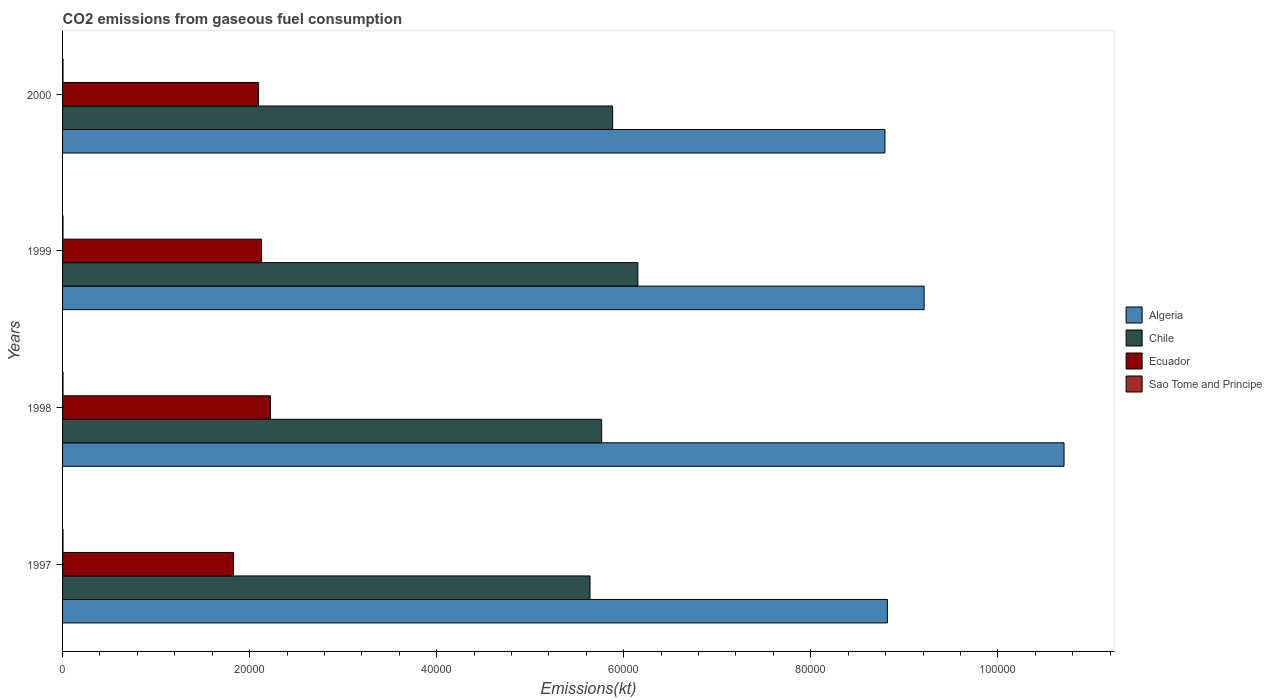Are the number of bars per tick equal to the number of legend labels?
Your response must be concise. Yes. Are the number of bars on each tick of the Y-axis equal?
Provide a short and direct response. Yes. What is the amount of CO2 emitted in Chile in 1999?
Provide a short and direct response. 6.15e+04. Across all years, what is the maximum amount of CO2 emitted in Sao Tome and Principe?
Provide a short and direct response. 47.67. Across all years, what is the minimum amount of CO2 emitted in Ecuador?
Your answer should be very brief. 1.83e+04. In which year was the amount of CO2 emitted in Ecuador maximum?
Offer a very short reply. 1998. What is the total amount of CO2 emitted in Ecuador in the graph?
Keep it short and to the point. 8.27e+04. What is the difference between the amount of CO2 emitted in Chile in 1997 and that in 1998?
Provide a short and direct response. -1246.78. What is the difference between the amount of CO2 emitted in Algeria in 1998 and the amount of CO2 emitted in Ecuador in 1999?
Keep it short and to the point. 8.58e+04. What is the average amount of CO2 emitted in Sao Tome and Principe per year?
Make the answer very short. 47.67. In the year 1999, what is the difference between the amount of CO2 emitted in Ecuador and amount of CO2 emitted in Chile?
Provide a succinct answer. -4.02e+04. In how many years, is the amount of CO2 emitted in Chile greater than 76000 kt?
Provide a short and direct response. 0. What is the ratio of the amount of CO2 emitted in Chile in 1997 to that in 1999?
Your answer should be compact. 0.92. Is the amount of CO2 emitted in Sao Tome and Principe in 1999 less than that in 2000?
Your answer should be very brief. No. Is the difference between the amount of CO2 emitted in Ecuador in 1997 and 1998 greater than the difference between the amount of CO2 emitted in Chile in 1997 and 1998?
Keep it short and to the point. No. What is the difference between the highest and the second highest amount of CO2 emitted in Ecuador?
Your answer should be very brief. 957.09. What is the difference between the highest and the lowest amount of CO2 emitted in Ecuador?
Your answer should be very brief. 3953.03. Is the sum of the amount of CO2 emitted in Ecuador in 1997 and 1999 greater than the maximum amount of CO2 emitted in Chile across all years?
Give a very brief answer. No. What does the 1st bar from the bottom in 1997 represents?
Give a very brief answer. Algeria. Are the values on the major ticks of X-axis written in scientific E-notation?
Make the answer very short. No. Does the graph contain grids?
Keep it short and to the point. No. How many legend labels are there?
Your answer should be compact. 4. How are the legend labels stacked?
Give a very brief answer. Vertical. What is the title of the graph?
Provide a succinct answer. CO2 emissions from gaseous fuel consumption. What is the label or title of the X-axis?
Your answer should be compact. Emissions(kt). What is the Emissions(kt) of Algeria in 1997?
Offer a very short reply. 8.82e+04. What is the Emissions(kt) in Chile in 1997?
Offer a very short reply. 5.64e+04. What is the Emissions(kt) of Ecuador in 1997?
Offer a very short reply. 1.83e+04. What is the Emissions(kt) of Sao Tome and Principe in 1997?
Your answer should be compact. 47.67. What is the Emissions(kt) in Algeria in 1998?
Give a very brief answer. 1.07e+05. What is the Emissions(kt) of Chile in 1998?
Make the answer very short. 5.76e+04. What is the Emissions(kt) of Ecuador in 1998?
Keep it short and to the point. 2.22e+04. What is the Emissions(kt) of Sao Tome and Principe in 1998?
Offer a terse response. 47.67. What is the Emissions(kt) in Algeria in 1999?
Keep it short and to the point. 9.21e+04. What is the Emissions(kt) of Chile in 1999?
Keep it short and to the point. 6.15e+04. What is the Emissions(kt) in Ecuador in 1999?
Provide a short and direct response. 2.13e+04. What is the Emissions(kt) in Sao Tome and Principe in 1999?
Keep it short and to the point. 47.67. What is the Emissions(kt) of Algeria in 2000?
Provide a succinct answer. 8.79e+04. What is the Emissions(kt) of Chile in 2000?
Provide a succinct answer. 5.88e+04. What is the Emissions(kt) in Ecuador in 2000?
Offer a very short reply. 2.09e+04. What is the Emissions(kt) in Sao Tome and Principe in 2000?
Keep it short and to the point. 47.67. Across all years, what is the maximum Emissions(kt) in Algeria?
Ensure brevity in your answer.  1.07e+05. Across all years, what is the maximum Emissions(kt) in Chile?
Make the answer very short. 6.15e+04. Across all years, what is the maximum Emissions(kt) of Ecuador?
Your answer should be compact. 2.22e+04. Across all years, what is the maximum Emissions(kt) of Sao Tome and Principe?
Keep it short and to the point. 47.67. Across all years, what is the minimum Emissions(kt) in Algeria?
Your response must be concise. 8.79e+04. Across all years, what is the minimum Emissions(kt) in Chile?
Give a very brief answer. 5.64e+04. Across all years, what is the minimum Emissions(kt) of Ecuador?
Keep it short and to the point. 1.83e+04. Across all years, what is the minimum Emissions(kt) of Sao Tome and Principe?
Offer a very short reply. 47.67. What is the total Emissions(kt) in Algeria in the graph?
Ensure brevity in your answer.  3.75e+05. What is the total Emissions(kt) in Chile in the graph?
Your answer should be very brief. 2.34e+05. What is the total Emissions(kt) of Ecuador in the graph?
Your answer should be very brief. 8.27e+04. What is the total Emissions(kt) in Sao Tome and Principe in the graph?
Your answer should be compact. 190.68. What is the difference between the Emissions(kt) in Algeria in 1997 and that in 1998?
Provide a short and direct response. -1.89e+04. What is the difference between the Emissions(kt) of Chile in 1997 and that in 1998?
Offer a very short reply. -1246.78. What is the difference between the Emissions(kt) in Ecuador in 1997 and that in 1998?
Your answer should be compact. -3953.03. What is the difference between the Emissions(kt) in Algeria in 1997 and that in 1999?
Your response must be concise. -3923.69. What is the difference between the Emissions(kt) of Chile in 1997 and that in 1999?
Ensure brevity in your answer.  -5119.13. What is the difference between the Emissions(kt) in Ecuador in 1997 and that in 1999?
Your answer should be compact. -2995.94. What is the difference between the Emissions(kt) in Sao Tome and Principe in 1997 and that in 1999?
Provide a succinct answer. 0. What is the difference between the Emissions(kt) in Algeria in 1997 and that in 2000?
Provide a short and direct response. 264.02. What is the difference between the Emissions(kt) in Chile in 1997 and that in 2000?
Offer a terse response. -2420.22. What is the difference between the Emissions(kt) of Ecuador in 1997 and that in 2000?
Offer a terse response. -2665.91. What is the difference between the Emissions(kt) in Algeria in 1998 and that in 1999?
Offer a terse response. 1.50e+04. What is the difference between the Emissions(kt) in Chile in 1998 and that in 1999?
Ensure brevity in your answer.  -3872.35. What is the difference between the Emissions(kt) of Ecuador in 1998 and that in 1999?
Provide a succinct answer. 957.09. What is the difference between the Emissions(kt) in Sao Tome and Principe in 1998 and that in 1999?
Your answer should be very brief. 0. What is the difference between the Emissions(kt) of Algeria in 1998 and that in 2000?
Your answer should be compact. 1.91e+04. What is the difference between the Emissions(kt) of Chile in 1998 and that in 2000?
Provide a short and direct response. -1173.44. What is the difference between the Emissions(kt) in Ecuador in 1998 and that in 2000?
Offer a very short reply. 1287.12. What is the difference between the Emissions(kt) of Algeria in 1999 and that in 2000?
Make the answer very short. 4187.71. What is the difference between the Emissions(kt) of Chile in 1999 and that in 2000?
Keep it short and to the point. 2698.91. What is the difference between the Emissions(kt) of Ecuador in 1999 and that in 2000?
Make the answer very short. 330.03. What is the difference between the Emissions(kt) in Sao Tome and Principe in 1999 and that in 2000?
Ensure brevity in your answer.  0. What is the difference between the Emissions(kt) in Algeria in 1997 and the Emissions(kt) in Chile in 1998?
Offer a very short reply. 3.06e+04. What is the difference between the Emissions(kt) in Algeria in 1997 and the Emissions(kt) in Ecuador in 1998?
Provide a succinct answer. 6.60e+04. What is the difference between the Emissions(kt) of Algeria in 1997 and the Emissions(kt) of Sao Tome and Principe in 1998?
Ensure brevity in your answer.  8.81e+04. What is the difference between the Emissions(kt) of Chile in 1997 and the Emissions(kt) of Ecuador in 1998?
Offer a terse response. 3.42e+04. What is the difference between the Emissions(kt) of Chile in 1997 and the Emissions(kt) of Sao Tome and Principe in 1998?
Offer a very short reply. 5.63e+04. What is the difference between the Emissions(kt) in Ecuador in 1997 and the Emissions(kt) in Sao Tome and Principe in 1998?
Keep it short and to the point. 1.82e+04. What is the difference between the Emissions(kt) of Algeria in 1997 and the Emissions(kt) of Chile in 1999?
Provide a short and direct response. 2.67e+04. What is the difference between the Emissions(kt) in Algeria in 1997 and the Emissions(kt) in Ecuador in 1999?
Your answer should be very brief. 6.69e+04. What is the difference between the Emissions(kt) in Algeria in 1997 and the Emissions(kt) in Sao Tome and Principe in 1999?
Provide a short and direct response. 8.81e+04. What is the difference between the Emissions(kt) in Chile in 1997 and the Emissions(kt) in Ecuador in 1999?
Ensure brevity in your answer.  3.51e+04. What is the difference between the Emissions(kt) in Chile in 1997 and the Emissions(kt) in Sao Tome and Principe in 1999?
Your response must be concise. 5.63e+04. What is the difference between the Emissions(kt) in Ecuador in 1997 and the Emissions(kt) in Sao Tome and Principe in 1999?
Your answer should be very brief. 1.82e+04. What is the difference between the Emissions(kt) of Algeria in 1997 and the Emissions(kt) of Chile in 2000?
Give a very brief answer. 2.94e+04. What is the difference between the Emissions(kt) of Algeria in 1997 and the Emissions(kt) of Ecuador in 2000?
Provide a short and direct response. 6.73e+04. What is the difference between the Emissions(kt) in Algeria in 1997 and the Emissions(kt) in Sao Tome and Principe in 2000?
Your answer should be compact. 8.81e+04. What is the difference between the Emissions(kt) in Chile in 1997 and the Emissions(kt) in Ecuador in 2000?
Ensure brevity in your answer.  3.55e+04. What is the difference between the Emissions(kt) in Chile in 1997 and the Emissions(kt) in Sao Tome and Principe in 2000?
Keep it short and to the point. 5.63e+04. What is the difference between the Emissions(kt) of Ecuador in 1997 and the Emissions(kt) of Sao Tome and Principe in 2000?
Provide a short and direct response. 1.82e+04. What is the difference between the Emissions(kt) in Algeria in 1998 and the Emissions(kt) in Chile in 1999?
Offer a very short reply. 4.56e+04. What is the difference between the Emissions(kt) of Algeria in 1998 and the Emissions(kt) of Ecuador in 1999?
Your answer should be very brief. 8.58e+04. What is the difference between the Emissions(kt) of Algeria in 1998 and the Emissions(kt) of Sao Tome and Principe in 1999?
Ensure brevity in your answer.  1.07e+05. What is the difference between the Emissions(kt) in Chile in 1998 and the Emissions(kt) in Ecuador in 1999?
Keep it short and to the point. 3.64e+04. What is the difference between the Emissions(kt) of Chile in 1998 and the Emissions(kt) of Sao Tome and Principe in 1999?
Offer a terse response. 5.76e+04. What is the difference between the Emissions(kt) in Ecuador in 1998 and the Emissions(kt) in Sao Tome and Principe in 1999?
Your answer should be compact. 2.22e+04. What is the difference between the Emissions(kt) of Algeria in 1998 and the Emissions(kt) of Chile in 2000?
Make the answer very short. 4.83e+04. What is the difference between the Emissions(kt) in Algeria in 1998 and the Emissions(kt) in Ecuador in 2000?
Your answer should be compact. 8.61e+04. What is the difference between the Emissions(kt) of Algeria in 1998 and the Emissions(kt) of Sao Tome and Principe in 2000?
Your response must be concise. 1.07e+05. What is the difference between the Emissions(kt) of Chile in 1998 and the Emissions(kt) of Ecuador in 2000?
Give a very brief answer. 3.67e+04. What is the difference between the Emissions(kt) in Chile in 1998 and the Emissions(kt) in Sao Tome and Principe in 2000?
Your answer should be very brief. 5.76e+04. What is the difference between the Emissions(kt) in Ecuador in 1998 and the Emissions(kt) in Sao Tome and Principe in 2000?
Make the answer very short. 2.22e+04. What is the difference between the Emissions(kt) of Algeria in 1999 and the Emissions(kt) of Chile in 2000?
Ensure brevity in your answer.  3.33e+04. What is the difference between the Emissions(kt) in Algeria in 1999 and the Emissions(kt) in Ecuador in 2000?
Your response must be concise. 7.12e+04. What is the difference between the Emissions(kt) of Algeria in 1999 and the Emissions(kt) of Sao Tome and Principe in 2000?
Offer a very short reply. 9.21e+04. What is the difference between the Emissions(kt) of Chile in 1999 and the Emissions(kt) of Ecuador in 2000?
Offer a very short reply. 4.06e+04. What is the difference between the Emissions(kt) of Chile in 1999 and the Emissions(kt) of Sao Tome and Principe in 2000?
Make the answer very short. 6.15e+04. What is the difference between the Emissions(kt) of Ecuador in 1999 and the Emissions(kt) of Sao Tome and Principe in 2000?
Make the answer very short. 2.12e+04. What is the average Emissions(kt) in Algeria per year?
Your response must be concise. 9.38e+04. What is the average Emissions(kt) in Chile per year?
Your answer should be very brief. 5.86e+04. What is the average Emissions(kt) in Ecuador per year?
Your response must be concise. 2.07e+04. What is the average Emissions(kt) in Sao Tome and Principe per year?
Give a very brief answer. 47.67. In the year 1997, what is the difference between the Emissions(kt) of Algeria and Emissions(kt) of Chile?
Your answer should be very brief. 3.18e+04. In the year 1997, what is the difference between the Emissions(kt) of Algeria and Emissions(kt) of Ecuador?
Give a very brief answer. 6.99e+04. In the year 1997, what is the difference between the Emissions(kt) in Algeria and Emissions(kt) in Sao Tome and Principe?
Ensure brevity in your answer.  8.81e+04. In the year 1997, what is the difference between the Emissions(kt) of Chile and Emissions(kt) of Ecuador?
Ensure brevity in your answer.  3.81e+04. In the year 1997, what is the difference between the Emissions(kt) of Chile and Emissions(kt) of Sao Tome and Principe?
Offer a very short reply. 5.63e+04. In the year 1997, what is the difference between the Emissions(kt) in Ecuador and Emissions(kt) in Sao Tome and Principe?
Offer a very short reply. 1.82e+04. In the year 1998, what is the difference between the Emissions(kt) in Algeria and Emissions(kt) in Chile?
Offer a terse response. 4.94e+04. In the year 1998, what is the difference between the Emissions(kt) in Algeria and Emissions(kt) in Ecuador?
Offer a very short reply. 8.49e+04. In the year 1998, what is the difference between the Emissions(kt) in Algeria and Emissions(kt) in Sao Tome and Principe?
Make the answer very short. 1.07e+05. In the year 1998, what is the difference between the Emissions(kt) of Chile and Emissions(kt) of Ecuador?
Your response must be concise. 3.54e+04. In the year 1998, what is the difference between the Emissions(kt) of Chile and Emissions(kt) of Sao Tome and Principe?
Provide a short and direct response. 5.76e+04. In the year 1998, what is the difference between the Emissions(kt) in Ecuador and Emissions(kt) in Sao Tome and Principe?
Your answer should be very brief. 2.22e+04. In the year 1999, what is the difference between the Emissions(kt) in Algeria and Emissions(kt) in Chile?
Your response must be concise. 3.06e+04. In the year 1999, what is the difference between the Emissions(kt) in Algeria and Emissions(kt) in Ecuador?
Make the answer very short. 7.08e+04. In the year 1999, what is the difference between the Emissions(kt) of Algeria and Emissions(kt) of Sao Tome and Principe?
Your answer should be compact. 9.21e+04. In the year 1999, what is the difference between the Emissions(kt) of Chile and Emissions(kt) of Ecuador?
Your response must be concise. 4.02e+04. In the year 1999, what is the difference between the Emissions(kt) in Chile and Emissions(kt) in Sao Tome and Principe?
Your answer should be very brief. 6.15e+04. In the year 1999, what is the difference between the Emissions(kt) of Ecuador and Emissions(kt) of Sao Tome and Principe?
Keep it short and to the point. 2.12e+04. In the year 2000, what is the difference between the Emissions(kt) in Algeria and Emissions(kt) in Chile?
Ensure brevity in your answer.  2.91e+04. In the year 2000, what is the difference between the Emissions(kt) of Algeria and Emissions(kt) of Ecuador?
Your response must be concise. 6.70e+04. In the year 2000, what is the difference between the Emissions(kt) in Algeria and Emissions(kt) in Sao Tome and Principe?
Offer a terse response. 8.79e+04. In the year 2000, what is the difference between the Emissions(kt) of Chile and Emissions(kt) of Ecuador?
Offer a terse response. 3.79e+04. In the year 2000, what is the difference between the Emissions(kt) in Chile and Emissions(kt) in Sao Tome and Principe?
Your response must be concise. 5.88e+04. In the year 2000, what is the difference between the Emissions(kt) in Ecuador and Emissions(kt) in Sao Tome and Principe?
Give a very brief answer. 2.09e+04. What is the ratio of the Emissions(kt) of Algeria in 1997 to that in 1998?
Provide a short and direct response. 0.82. What is the ratio of the Emissions(kt) in Chile in 1997 to that in 1998?
Your response must be concise. 0.98. What is the ratio of the Emissions(kt) in Ecuador in 1997 to that in 1998?
Provide a short and direct response. 0.82. What is the ratio of the Emissions(kt) in Sao Tome and Principe in 1997 to that in 1998?
Provide a short and direct response. 1. What is the ratio of the Emissions(kt) of Algeria in 1997 to that in 1999?
Your answer should be very brief. 0.96. What is the ratio of the Emissions(kt) of Chile in 1997 to that in 1999?
Provide a succinct answer. 0.92. What is the ratio of the Emissions(kt) in Ecuador in 1997 to that in 1999?
Provide a succinct answer. 0.86. What is the ratio of the Emissions(kt) in Sao Tome and Principe in 1997 to that in 1999?
Give a very brief answer. 1. What is the ratio of the Emissions(kt) of Algeria in 1997 to that in 2000?
Give a very brief answer. 1. What is the ratio of the Emissions(kt) in Chile in 1997 to that in 2000?
Offer a very short reply. 0.96. What is the ratio of the Emissions(kt) of Ecuador in 1997 to that in 2000?
Give a very brief answer. 0.87. What is the ratio of the Emissions(kt) in Sao Tome and Principe in 1997 to that in 2000?
Give a very brief answer. 1. What is the ratio of the Emissions(kt) in Algeria in 1998 to that in 1999?
Offer a very short reply. 1.16. What is the ratio of the Emissions(kt) of Chile in 1998 to that in 1999?
Your answer should be compact. 0.94. What is the ratio of the Emissions(kt) of Ecuador in 1998 to that in 1999?
Offer a very short reply. 1.04. What is the ratio of the Emissions(kt) in Sao Tome and Principe in 1998 to that in 1999?
Give a very brief answer. 1. What is the ratio of the Emissions(kt) in Algeria in 1998 to that in 2000?
Provide a succinct answer. 1.22. What is the ratio of the Emissions(kt) in Chile in 1998 to that in 2000?
Provide a short and direct response. 0.98. What is the ratio of the Emissions(kt) in Ecuador in 1998 to that in 2000?
Make the answer very short. 1.06. What is the ratio of the Emissions(kt) of Sao Tome and Principe in 1998 to that in 2000?
Your answer should be compact. 1. What is the ratio of the Emissions(kt) of Algeria in 1999 to that in 2000?
Give a very brief answer. 1.05. What is the ratio of the Emissions(kt) of Chile in 1999 to that in 2000?
Your response must be concise. 1.05. What is the ratio of the Emissions(kt) of Ecuador in 1999 to that in 2000?
Your answer should be very brief. 1.02. What is the difference between the highest and the second highest Emissions(kt) in Algeria?
Give a very brief answer. 1.50e+04. What is the difference between the highest and the second highest Emissions(kt) of Chile?
Provide a short and direct response. 2698.91. What is the difference between the highest and the second highest Emissions(kt) in Ecuador?
Keep it short and to the point. 957.09. What is the difference between the highest and the second highest Emissions(kt) of Sao Tome and Principe?
Provide a short and direct response. 0. What is the difference between the highest and the lowest Emissions(kt) of Algeria?
Provide a short and direct response. 1.91e+04. What is the difference between the highest and the lowest Emissions(kt) of Chile?
Provide a succinct answer. 5119.13. What is the difference between the highest and the lowest Emissions(kt) of Ecuador?
Your answer should be compact. 3953.03. What is the difference between the highest and the lowest Emissions(kt) of Sao Tome and Principe?
Provide a short and direct response. 0. 